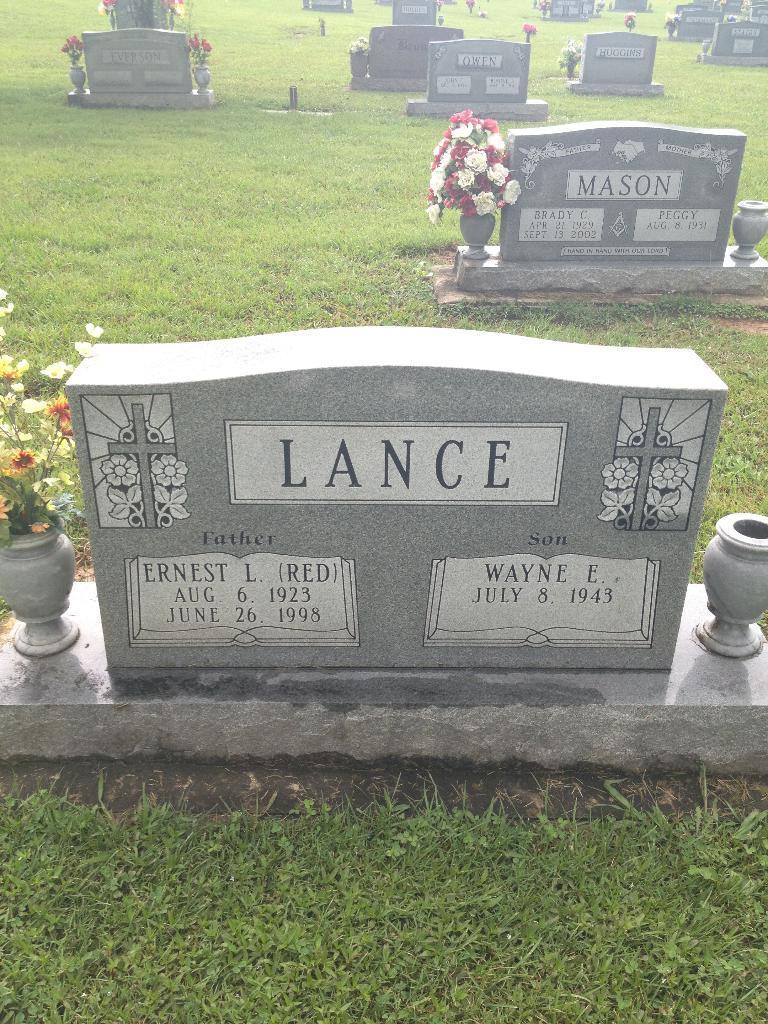Can you describe this image briefly? In this picture there are graves on the grassland in the image. 